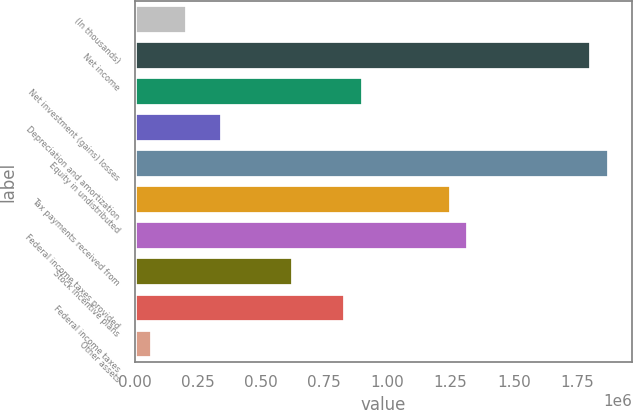Convert chart to OTSL. <chart><loc_0><loc_0><loc_500><loc_500><bar_chart><fcel>(In thousands)<fcel>Net income<fcel>Net investment (gains) losses<fcel>Depreciation and amortization<fcel>Equity in undistributed<fcel>Tax payments received from<fcel>Federal income taxes provided<fcel>Stock incentive plans<fcel>Federal income taxes<fcel>Other assets<nl><fcel>208478<fcel>1.80607e+06<fcel>903082<fcel>347399<fcel>1.87553e+06<fcel>1.25038e+06<fcel>1.31984e+06<fcel>625241<fcel>833622<fcel>69557.4<nl></chart> 